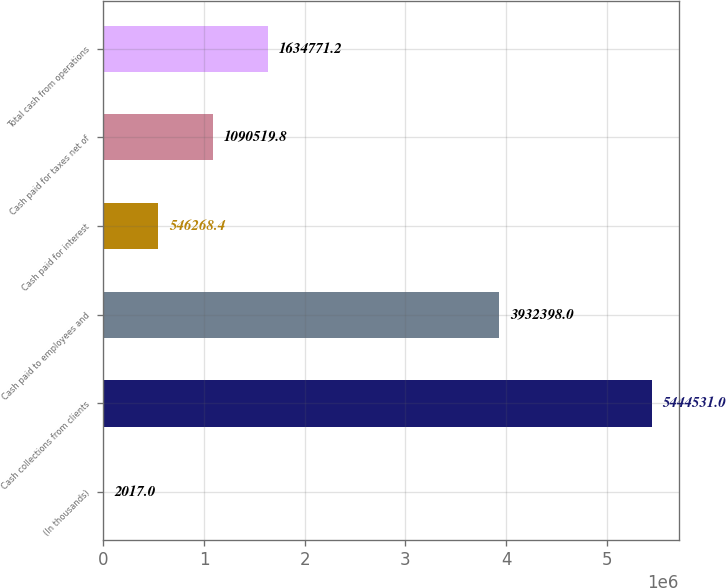Convert chart. <chart><loc_0><loc_0><loc_500><loc_500><bar_chart><fcel>(In thousands)<fcel>Cash collections from clients<fcel>Cash paid to employees and<fcel>Cash paid for interest<fcel>Cash paid for taxes net of<fcel>Total cash from operations<nl><fcel>2017<fcel>5.44453e+06<fcel>3.9324e+06<fcel>546268<fcel>1.09052e+06<fcel>1.63477e+06<nl></chart> 